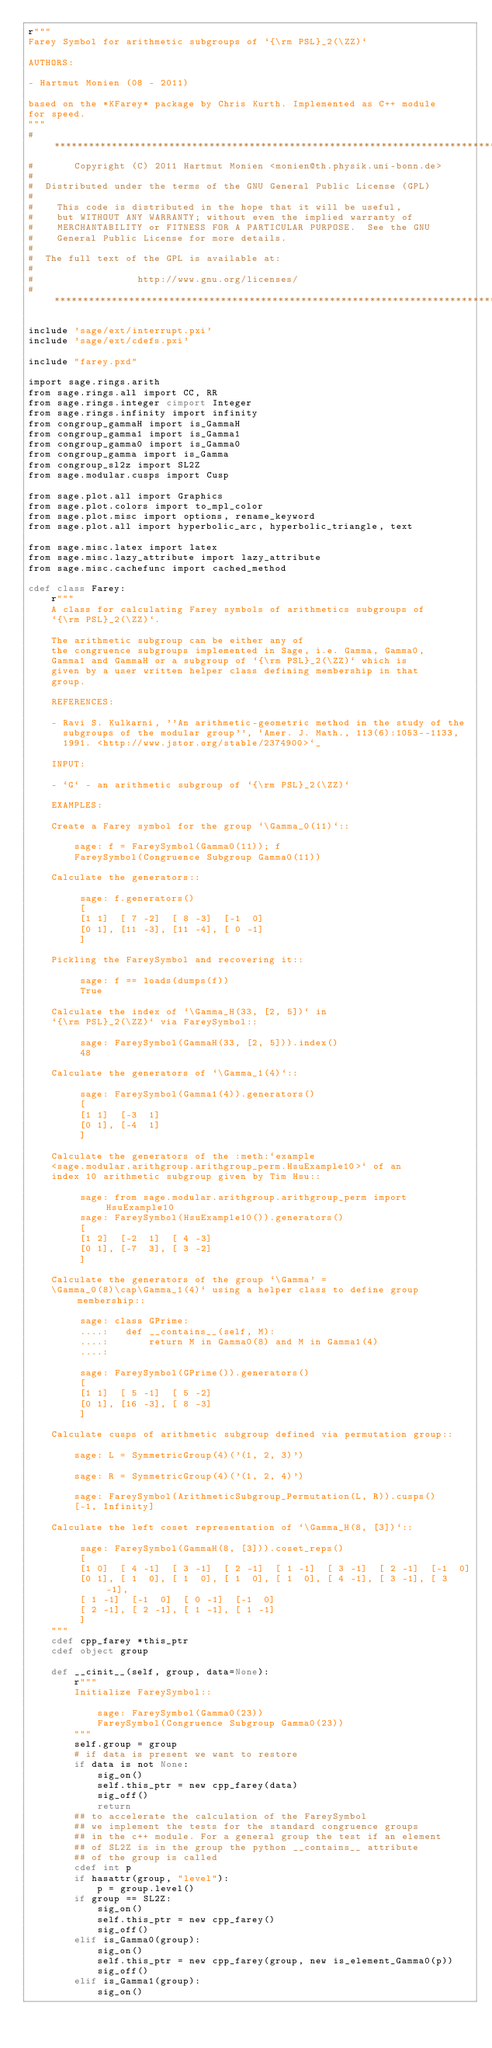<code> <loc_0><loc_0><loc_500><loc_500><_Cython_>r"""
Farey Symbol for arithmetic subgroups of `{\rm PSL}_2(\ZZ)`

AUTHORS:

- Hartmut Monien (08 - 2011)

based on the *KFarey* package by Chris Kurth. Implemented as C++ module
for speed.
"""
#*****************************************************************************
#       Copyright (C) 2011 Hartmut Monien <monien@th.physik.uni-bonn.de>
#
#  Distributed under the terms of the GNU General Public License (GPL)
#
#    This code is distributed in the hope that it will be useful,
#    but WITHOUT ANY WARRANTY; without even the implied warranty of
#    MERCHANTABILITY or FITNESS FOR A PARTICULAR PURPOSE.  See the GNU
#    General Public License for more details.
#
#  The full text of the GPL is available at:
#
#                  http://www.gnu.org/licenses/
#*****************************************************************************

include 'sage/ext/interrupt.pxi'
include 'sage/ext/cdefs.pxi'

include "farey.pxd"

import sage.rings.arith
from sage.rings.all import CC, RR
from sage.rings.integer cimport Integer
from sage.rings.infinity import infinity
from congroup_gammaH import is_GammaH
from congroup_gamma1 import is_Gamma1
from congroup_gamma0 import is_Gamma0
from congroup_gamma import is_Gamma
from congroup_sl2z import SL2Z
from sage.modular.cusps import Cusp

from sage.plot.all import Graphics
from sage.plot.colors import to_mpl_color
from sage.plot.misc import options, rename_keyword
from sage.plot.all import hyperbolic_arc, hyperbolic_triangle, text

from sage.misc.latex import latex
from sage.misc.lazy_attribute import lazy_attribute
from sage.misc.cachefunc import cached_method

cdef class Farey:
    r"""
    A class for calculating Farey symbols of arithmetics subgroups of
    `{\rm PSL}_2(\ZZ)`.

    The arithmetic subgroup can be either any of
    the congruence subgroups implemented in Sage, i.e. Gamma, Gamma0,
    Gamma1 and GammaH or a subgroup of `{\rm PSL}_2(\ZZ)` which is
    given by a user written helper class defining membership in that
    group.

    REFERENCES:

    - Ravi S. Kulkarni, ''An arithmetic-geometric method in the study of the
      subgroups of the modular group'', `Amer. J. Math., 113(6):1053--1133,
      1991. <http://www.jstor.org/stable/2374900>`_

    INPUT:

    - `G` - an arithmetic subgroup of `{\rm PSL}_2(\ZZ)`

    EXAMPLES:

    Create a Farey symbol for the group `\Gamma_0(11)`::

        sage: f = FareySymbol(Gamma0(11)); f
        FareySymbol(Congruence Subgroup Gamma0(11))

    Calculate the generators::

         sage: f.generators()
         [
         [1 1]  [ 7 -2]  [ 8 -3]  [-1  0]
         [0 1], [11 -3], [11 -4], [ 0 -1]
         ]

    Pickling the FareySymbol and recovering it::

         sage: f == loads(dumps(f))
         True

    Calculate the index of `\Gamma_H(33, [2, 5])` in
    `{\rm PSL}_2(\ZZ)` via FareySymbol::

         sage: FareySymbol(GammaH(33, [2, 5])).index()
         48

    Calculate the generators of `\Gamma_1(4)`::

         sage: FareySymbol(Gamma1(4)).generators()
         [
         [1 1]  [-3  1]
         [0 1], [-4  1]
         ]

    Calculate the generators of the :meth:`example
    <sage.modular.arithgroup.arithgroup_perm.HsuExample10>` of an
    index 10 arithmetic subgroup given by Tim Hsu::

         sage: from sage.modular.arithgroup.arithgroup_perm import HsuExample10
         sage: FareySymbol(HsuExample10()).generators()
         [
         [1 2]  [-2  1]  [ 4 -3]
         [0 1], [-7  3], [ 3 -2]
         ]

    Calculate the generators of the group `\Gamma' =
    \Gamma_0(8)\cap\Gamma_1(4)` using a helper class to define group membership::

         sage: class GPrime:
         ....:   def __contains__(self, M):
         ....:       return M in Gamma0(8) and M in Gamma1(4)
         ....:

         sage: FareySymbol(GPrime()).generators()
         [
         [1 1]  [ 5 -1]  [ 5 -2]
         [0 1], [16 -3], [ 8 -3]
         ]

    Calculate cusps of arithmetic subgroup defined via permutation group::

        sage: L = SymmetricGroup(4)('(1, 2, 3)')

        sage: R = SymmetricGroup(4)('(1, 2, 4)')

        sage: FareySymbol(ArithmeticSubgroup_Permutation(L, R)).cusps()
        [-1, Infinity]

    Calculate the left coset representation of `\Gamma_H(8, [3])`::

         sage: FareySymbol(GammaH(8, [3])).coset_reps()
         [
         [1 0]  [ 4 -1]  [ 3 -1]  [ 2 -1]  [ 1 -1]  [ 3 -1]  [ 2 -1]  [-1  0]
         [0 1], [ 1  0], [ 1  0], [ 1  0], [ 1  0], [ 4 -1], [ 3 -1], [ 3 -1],
         [ 1 -1]  [-1  0]  [ 0 -1]  [-1  0]
         [ 2 -1], [ 2 -1], [ 1 -1], [ 1 -1]
         ]
    """
    cdef cpp_farey *this_ptr
    cdef object group

    def __cinit__(self, group, data=None):
        r"""
        Initialize FareySymbol::

            sage: FareySymbol(Gamma0(23))
            FareySymbol(Congruence Subgroup Gamma0(23))
        """
        self.group = group
        # if data is present we want to restore
        if data is not None:
            sig_on()
            self.this_ptr = new cpp_farey(data)
            sig_off()
            return
        ## to accelerate the calculation of the FareySymbol
        ## we implement the tests for the standard congruence groups
        ## in the c++ module. For a general group the test if an element
        ## of SL2Z is in the group the python __contains__ attribute
        ## of the group is called
        cdef int p
        if hasattr(group, "level"):
            p = group.level()
        if group == SL2Z:
            sig_on()
            self.this_ptr = new cpp_farey()
            sig_off()
        elif is_Gamma0(group):
            sig_on()
            self.this_ptr = new cpp_farey(group, new is_element_Gamma0(p))
            sig_off()
        elif is_Gamma1(group):
            sig_on()</code> 